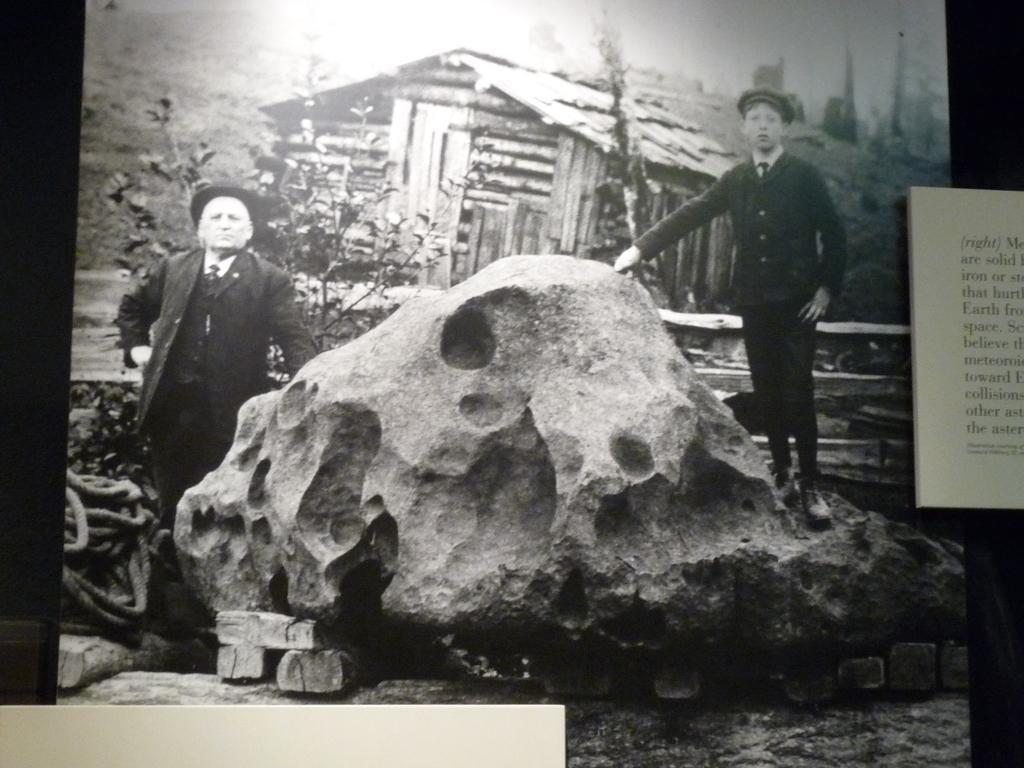Can you describe this image briefly? It is a black and white picture. In the center of the image we can see one stone,rope,woods and two persons are standing and they are wearing hats. In the background we can see poles,plants,one wooden house,fence and few other objects. On the right side of the image,we can see some text. 